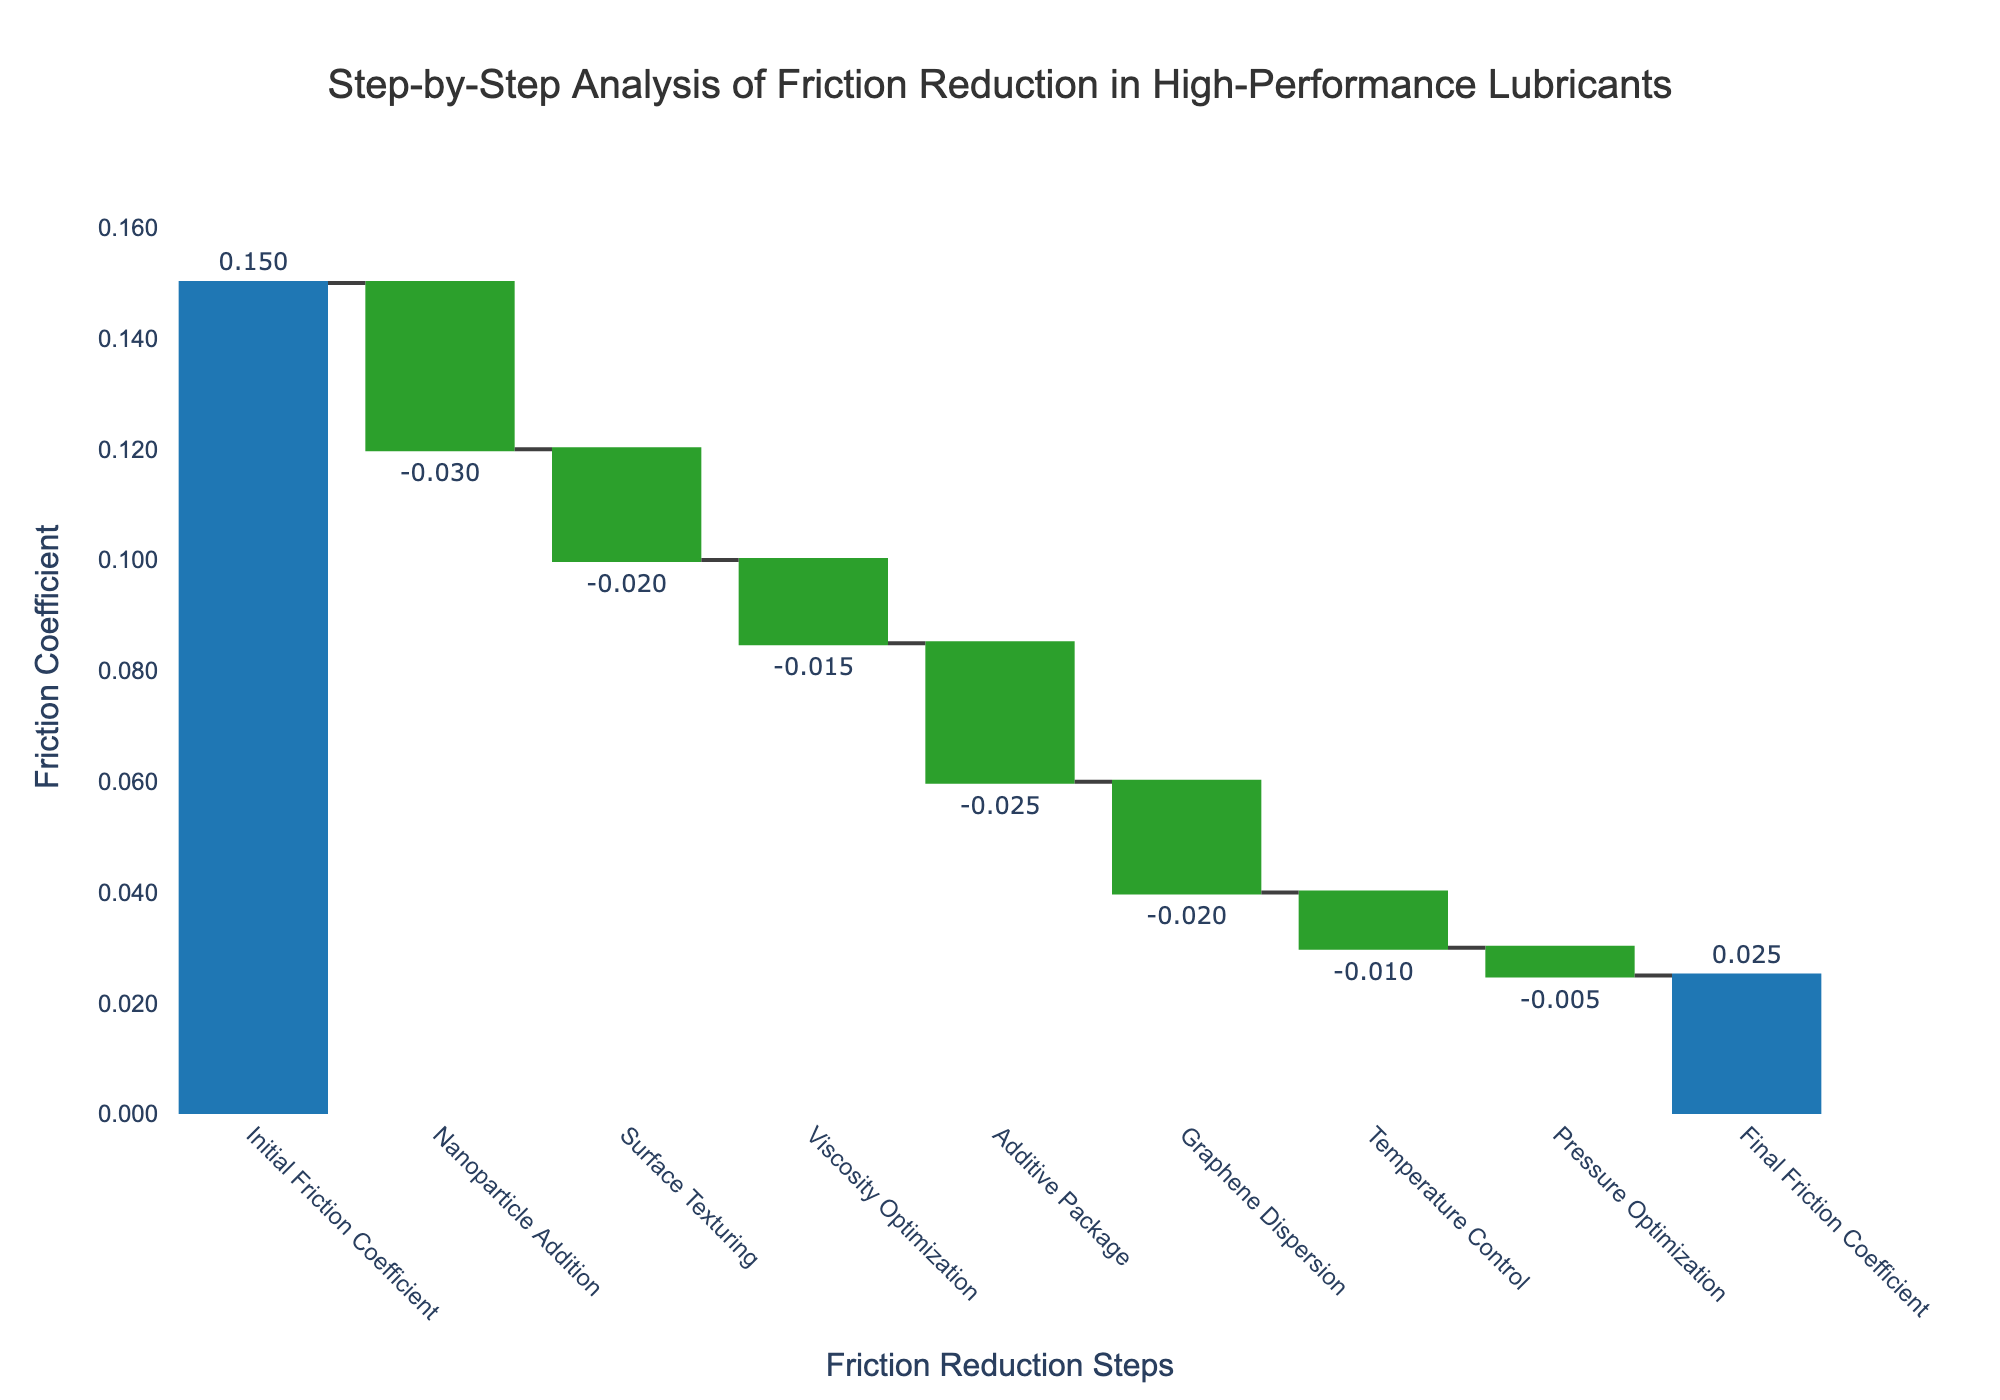What's the initial friction coefficient? The initial friction coefficient is mentioned in the first step of the data series, which is labeled "Initial Friction Coefficient". This value is directly shown on the chart.
Answer: 0.15 What is the final friction coefficient? The final friction coefficient is the last value in the sequence, named "Final Friction Coefficient", as labeled on the chart. This value is also directly indicated.
Answer: 0.025 Which step contributes the most to the reduction of the friction coefficient? To determine the step that reduces the friction coefficient the most, examine the negative values and identify the largest one in magnitude. The step "Nanoparticle Addition" has the largest negative value (-0.03).
Answer: Nanoparticle Addition What is the overall reduction in the friction coefficient from the initial to the final values? Calculate the difference between the initial friction coefficient (0.15) and the final friction coefficient (0.025). Subtract the final value from the initial value: 0.15 - 0.025.
Answer: 0.125 How many steps in total contribute to the friction reduction process? Count the number of steps listed in the waterfall chart, excluding the initial and final friction coefficients. These contributors are Nanoparticle Addition, Surface Texturing, Viscosity Optimization, Additive Package, Graphene Dispersion, Temperature Control, and Pressure Optimization.
Answer: 7 Which step has the smallest impact on reducing friction? Identify the step with the smallest negative value. The "Pressure Optimization" step shows the smallest impact with a value of -0.005.
Answer: Pressure Optimization Did any step increase the friction coefficient? Review the values; in a waterfall chart, positive values typically indicate an increase. In this case, all intermediate values are negative, indicating none of the steps increased the friction coefficient.
Answer: No What is the combined effect of "Viscosity Optimization" and "Graphene Dispersion"? Add the values of "Viscosity Optimization" (-0.015) and "Graphene Dispersion" (-0.02). The combined effect is -0.015 + -0.02.
Answer: -0.035 Which step is the second largest contributor to friction reduction? Exclude the largest reduction step ("Nanoparticle Addition") and identify the next largest negative value. The "Additive Package" step, with a value of -0.025, is the second largest contributor.
Answer: Additive Package 